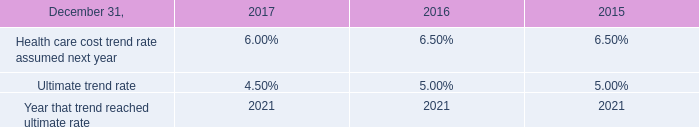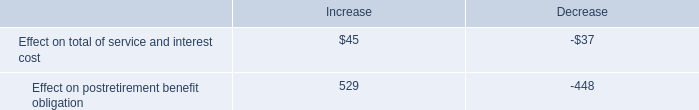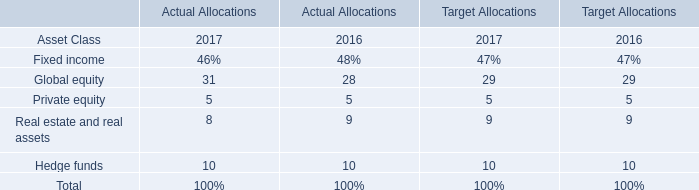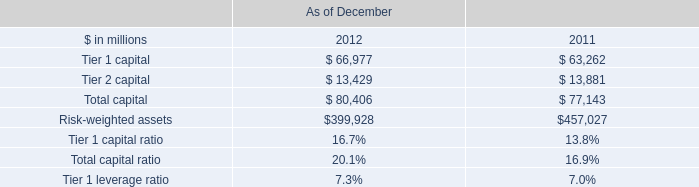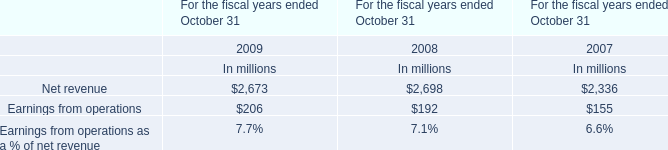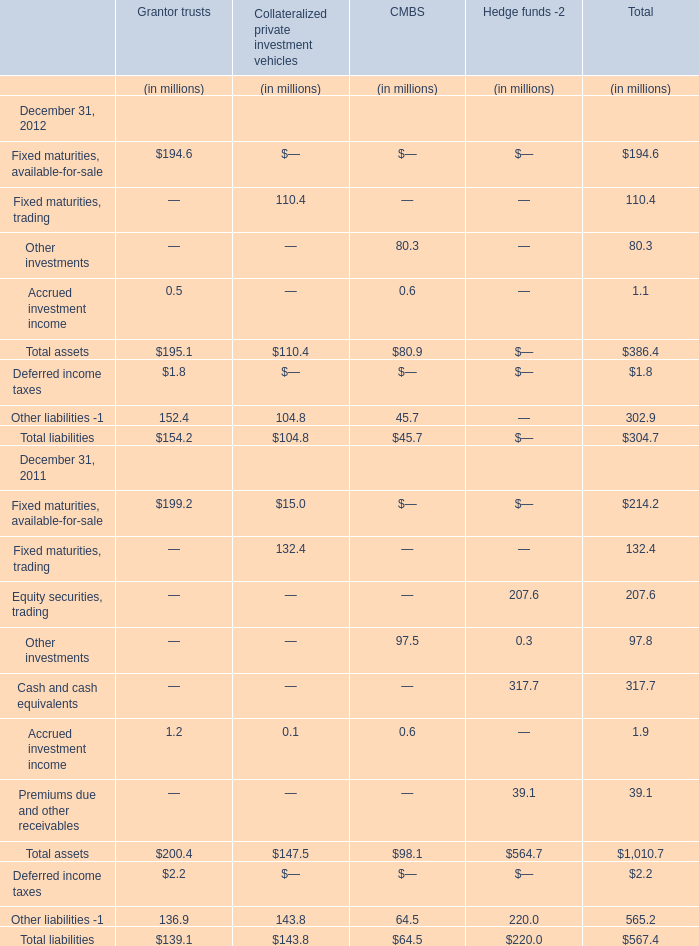What's the total value of all elementthat are smaller than10000 in 2012 for total? 
Computations: (((((((194.6 + 110.4) + 80.3) + 1.1) + 386.4) + 1.8) + 302.9) + 304.7)
Answer: 1382.2. 